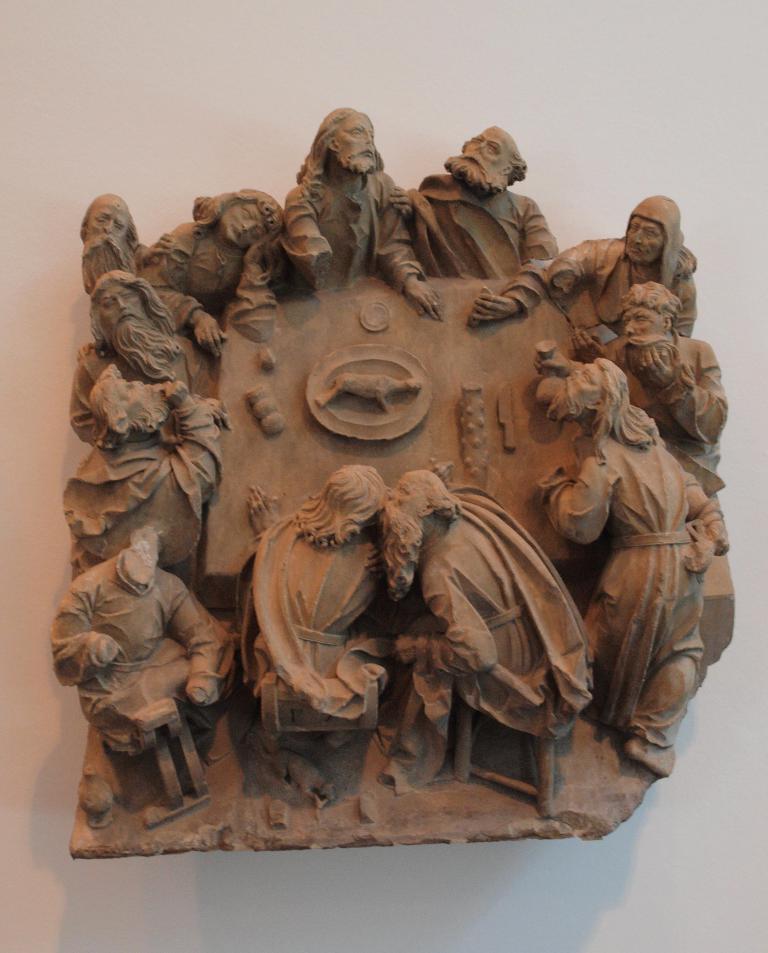How would you summarize this image in a sentence or two? In the picture there is a statue present on the wall. 